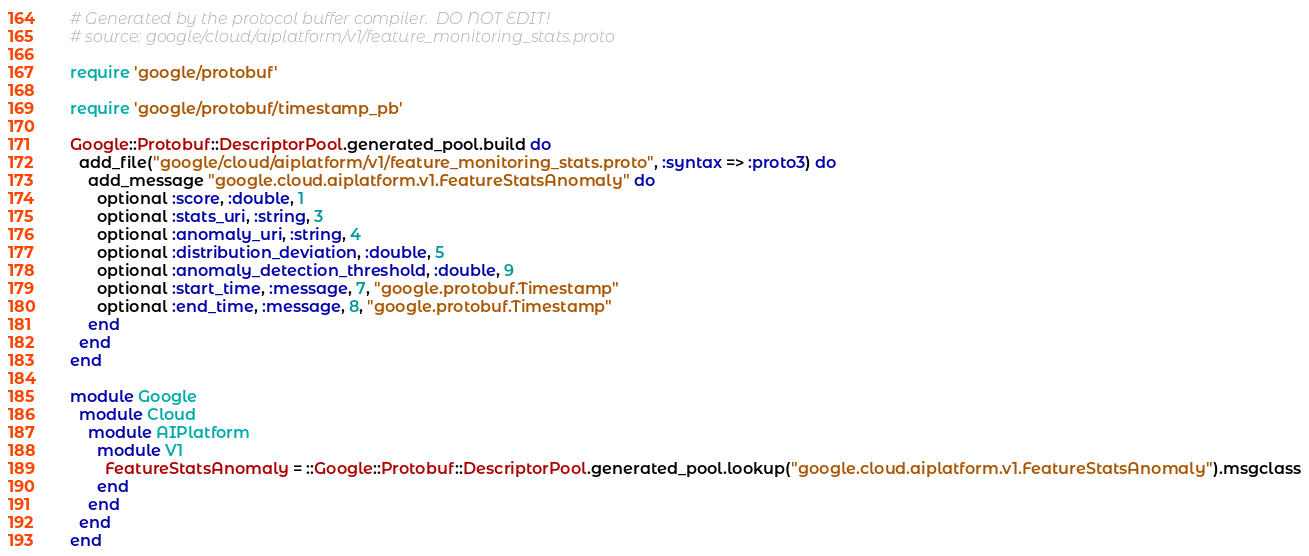<code> <loc_0><loc_0><loc_500><loc_500><_Ruby_># Generated by the protocol buffer compiler.  DO NOT EDIT!
# source: google/cloud/aiplatform/v1/feature_monitoring_stats.proto

require 'google/protobuf'

require 'google/protobuf/timestamp_pb'

Google::Protobuf::DescriptorPool.generated_pool.build do
  add_file("google/cloud/aiplatform/v1/feature_monitoring_stats.proto", :syntax => :proto3) do
    add_message "google.cloud.aiplatform.v1.FeatureStatsAnomaly" do
      optional :score, :double, 1
      optional :stats_uri, :string, 3
      optional :anomaly_uri, :string, 4
      optional :distribution_deviation, :double, 5
      optional :anomaly_detection_threshold, :double, 9
      optional :start_time, :message, 7, "google.protobuf.Timestamp"
      optional :end_time, :message, 8, "google.protobuf.Timestamp"
    end
  end
end

module Google
  module Cloud
    module AIPlatform
      module V1
        FeatureStatsAnomaly = ::Google::Protobuf::DescriptorPool.generated_pool.lookup("google.cloud.aiplatform.v1.FeatureStatsAnomaly").msgclass
      end
    end
  end
end
</code> 